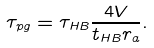Convert formula to latex. <formula><loc_0><loc_0><loc_500><loc_500>\tau _ { p g } = \tau _ { H B } \frac { 4 V } { t _ { H B } r _ { a } } .</formula> 